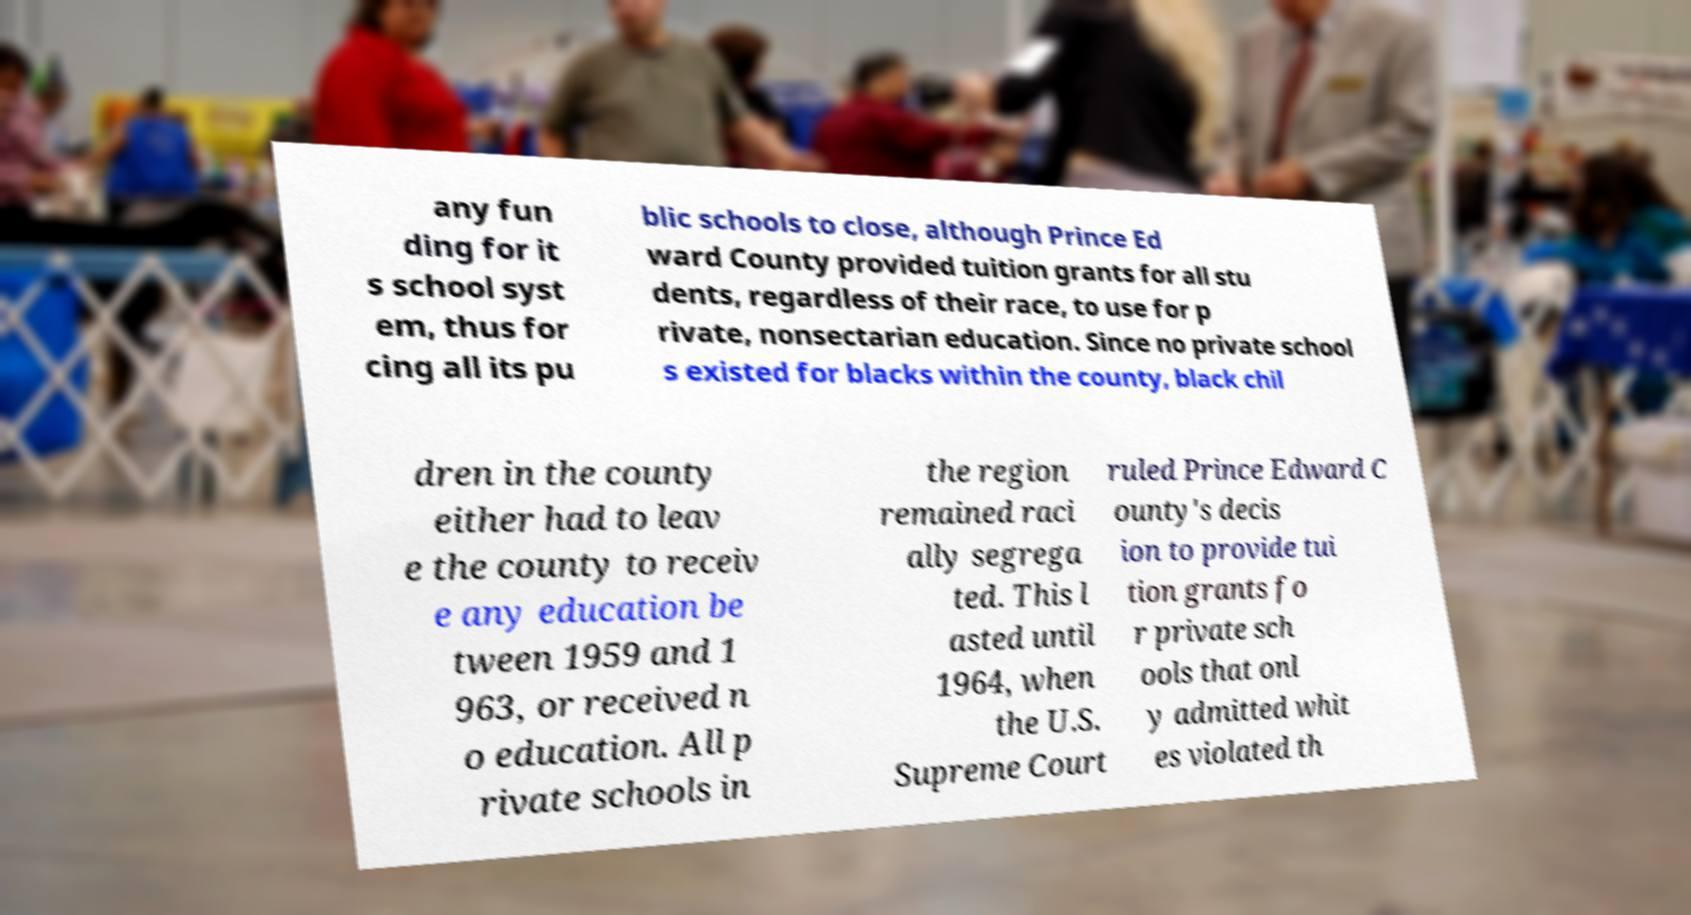Can you accurately transcribe the text from the provided image for me? any fun ding for it s school syst em, thus for cing all its pu blic schools to close, although Prince Ed ward County provided tuition grants for all stu dents, regardless of their race, to use for p rivate, nonsectarian education. Since no private school s existed for blacks within the county, black chil dren in the county either had to leav e the county to receiv e any education be tween 1959 and 1 963, or received n o education. All p rivate schools in the region remained raci ally segrega ted. This l asted until 1964, when the U.S. Supreme Court ruled Prince Edward C ounty's decis ion to provide tui tion grants fo r private sch ools that onl y admitted whit es violated th 